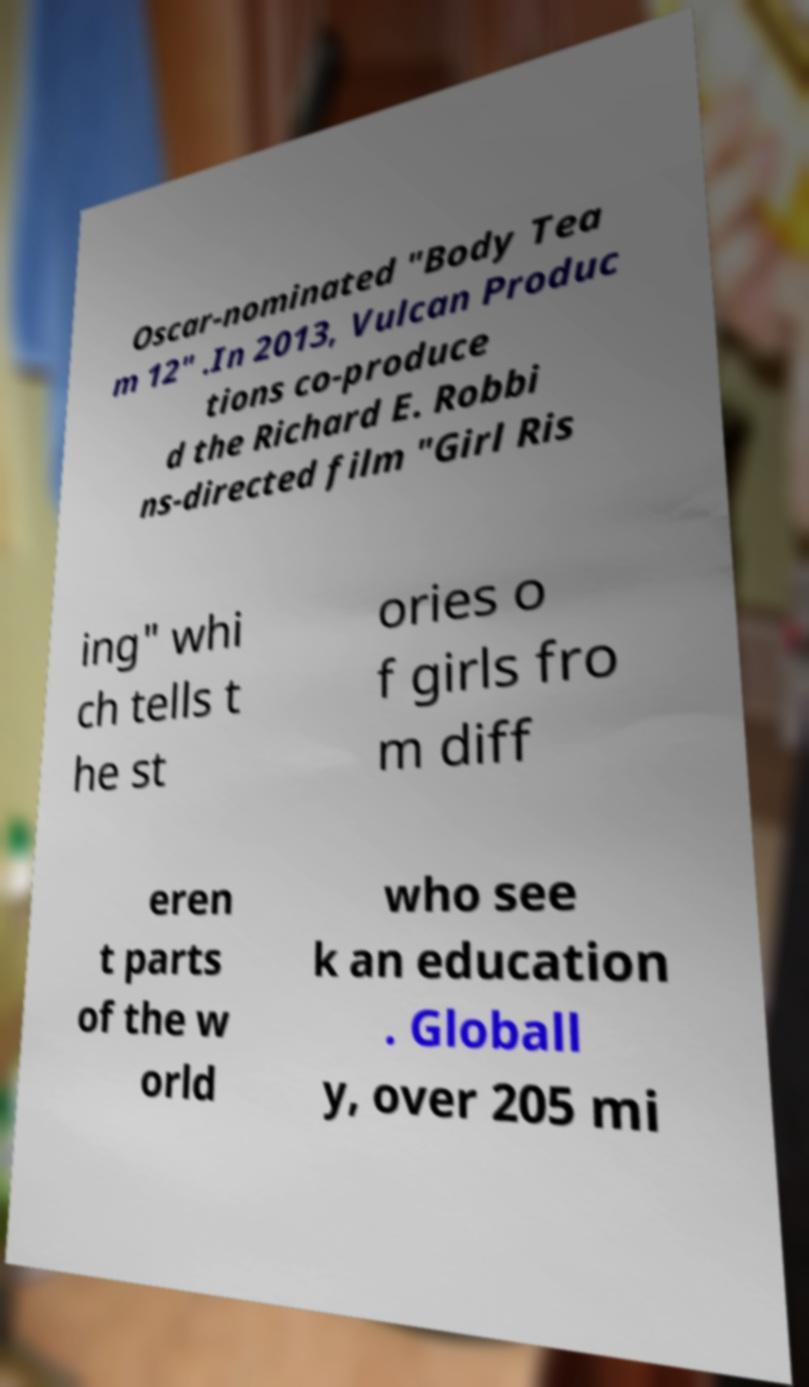There's text embedded in this image that I need extracted. Can you transcribe it verbatim? Oscar-nominated "Body Tea m 12" .In 2013, Vulcan Produc tions co-produce d the Richard E. Robbi ns-directed film "Girl Ris ing" whi ch tells t he st ories o f girls fro m diff eren t parts of the w orld who see k an education . Globall y, over 205 mi 